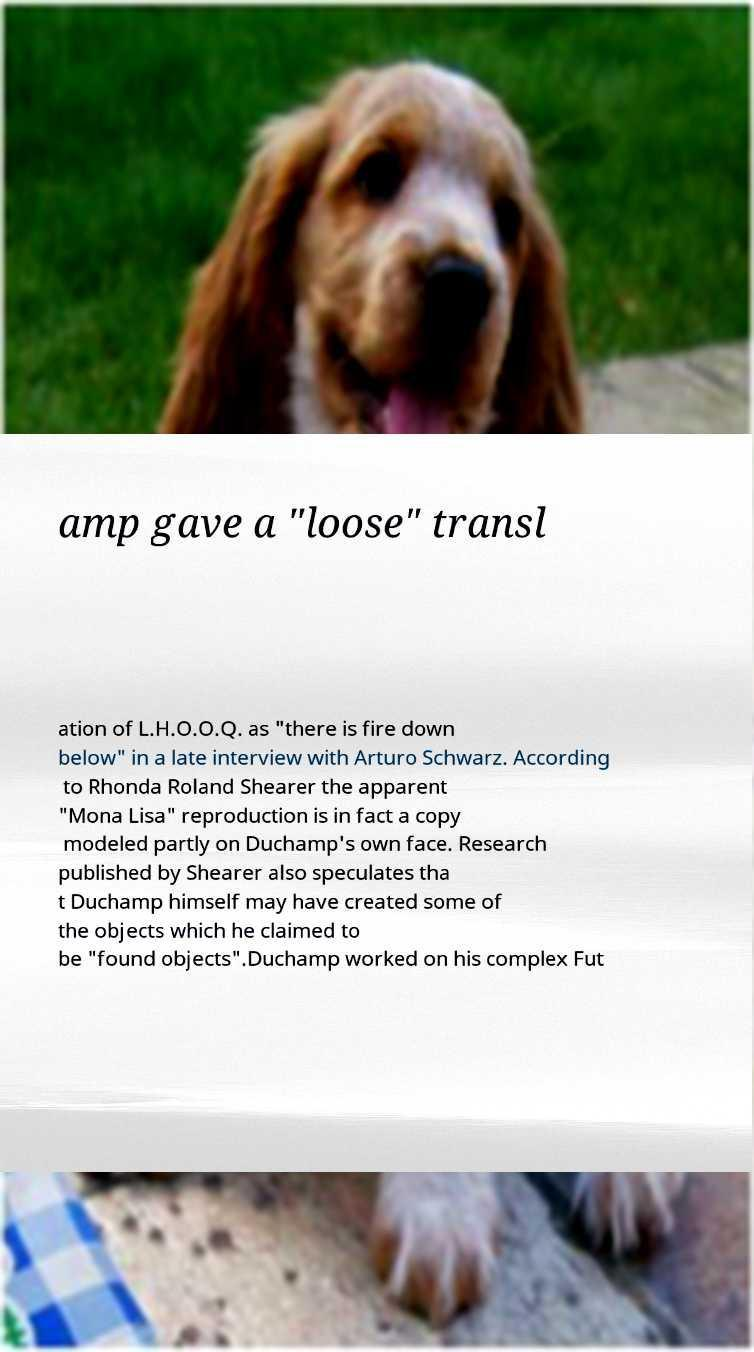There's text embedded in this image that I need extracted. Can you transcribe it verbatim? amp gave a "loose" transl ation of L.H.O.O.Q. as "there is fire down below" in a late interview with Arturo Schwarz. According to Rhonda Roland Shearer the apparent "Mona Lisa" reproduction is in fact a copy modeled partly on Duchamp's own face. Research published by Shearer also speculates tha t Duchamp himself may have created some of the objects which he claimed to be "found objects".Duchamp worked on his complex Fut 